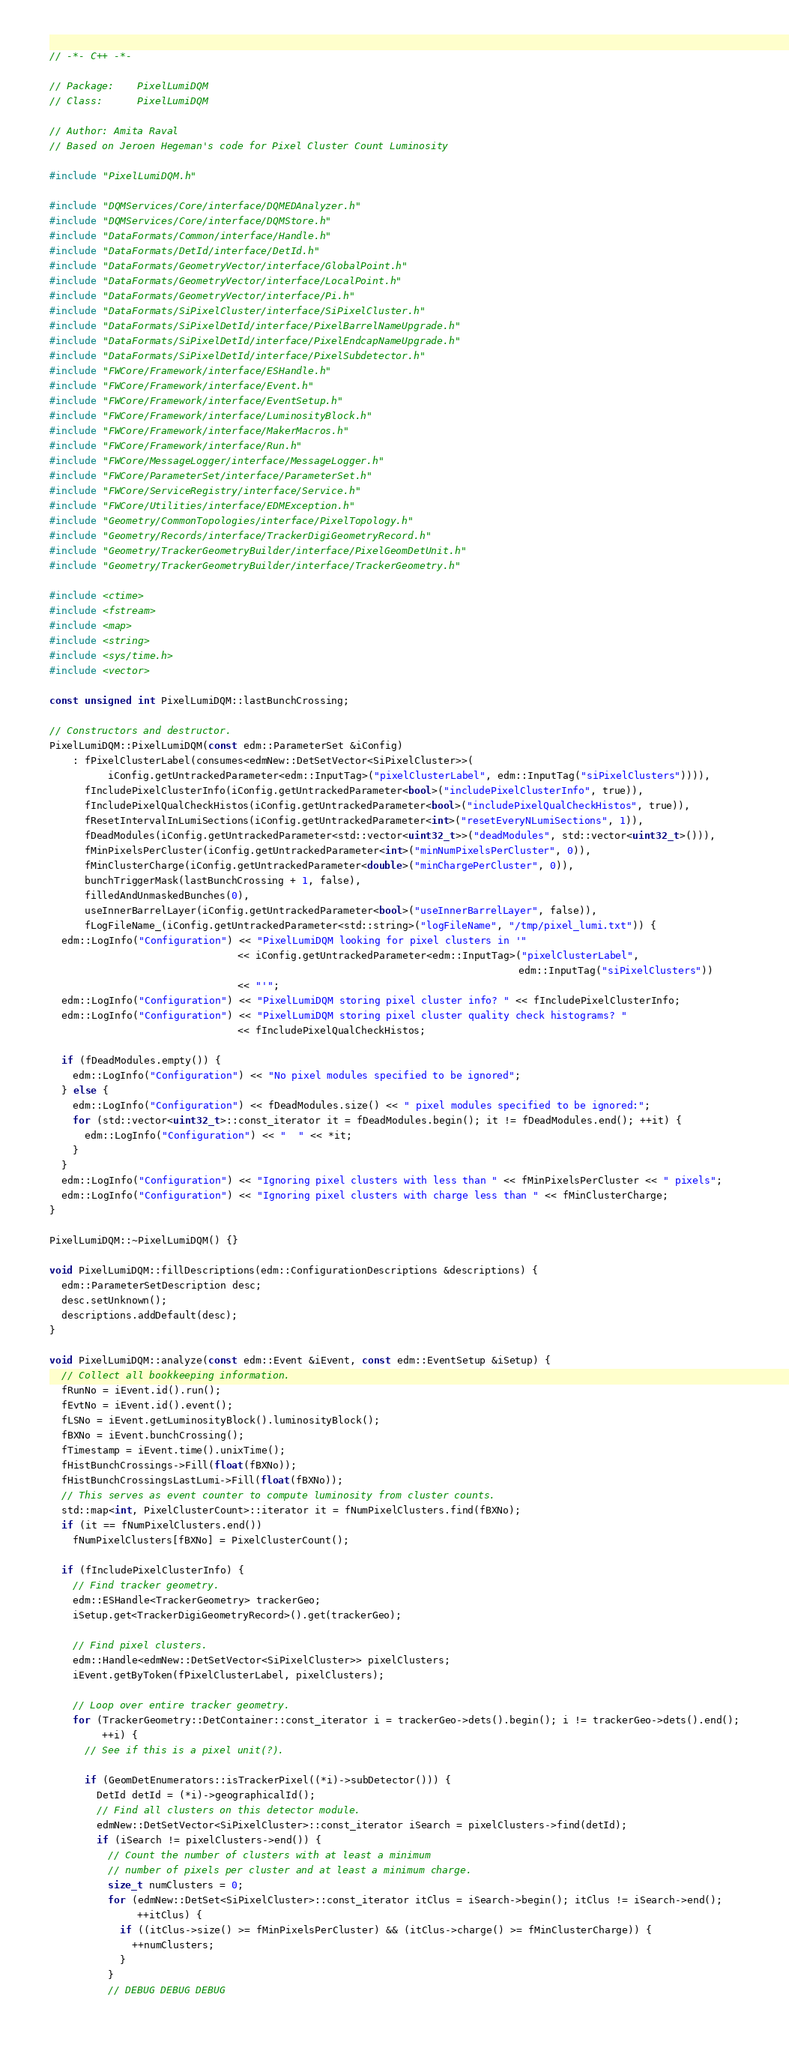Convert code to text. <code><loc_0><loc_0><loc_500><loc_500><_C++_>// -*- C++ -*-

// Package:    PixelLumiDQM
// Class:      PixelLumiDQM

// Author: Amita Raval
// Based on Jeroen Hegeman's code for Pixel Cluster Count Luminosity

#include "PixelLumiDQM.h"

#include "DQMServices/Core/interface/DQMEDAnalyzer.h"
#include "DQMServices/Core/interface/DQMStore.h"
#include "DataFormats/Common/interface/Handle.h"
#include "DataFormats/DetId/interface/DetId.h"
#include "DataFormats/GeometryVector/interface/GlobalPoint.h"
#include "DataFormats/GeometryVector/interface/LocalPoint.h"
#include "DataFormats/GeometryVector/interface/Pi.h"
#include "DataFormats/SiPixelCluster/interface/SiPixelCluster.h"
#include "DataFormats/SiPixelDetId/interface/PixelBarrelNameUpgrade.h"
#include "DataFormats/SiPixelDetId/interface/PixelEndcapNameUpgrade.h"
#include "DataFormats/SiPixelDetId/interface/PixelSubdetector.h"
#include "FWCore/Framework/interface/ESHandle.h"
#include "FWCore/Framework/interface/Event.h"
#include "FWCore/Framework/interface/EventSetup.h"
#include "FWCore/Framework/interface/LuminosityBlock.h"
#include "FWCore/Framework/interface/MakerMacros.h"
#include "FWCore/Framework/interface/Run.h"
#include "FWCore/MessageLogger/interface/MessageLogger.h"
#include "FWCore/ParameterSet/interface/ParameterSet.h"
#include "FWCore/ServiceRegistry/interface/Service.h"
#include "FWCore/Utilities/interface/EDMException.h"
#include "Geometry/CommonTopologies/interface/PixelTopology.h"
#include "Geometry/Records/interface/TrackerDigiGeometryRecord.h"
#include "Geometry/TrackerGeometryBuilder/interface/PixelGeomDetUnit.h"
#include "Geometry/TrackerGeometryBuilder/interface/TrackerGeometry.h"

#include <ctime>
#include <fstream>
#include <map>
#include <string>
#include <sys/time.h>
#include <vector>

const unsigned int PixelLumiDQM::lastBunchCrossing;

// Constructors and destructor.
PixelLumiDQM::PixelLumiDQM(const edm::ParameterSet &iConfig)
    : fPixelClusterLabel(consumes<edmNew::DetSetVector<SiPixelCluster>>(
          iConfig.getUntrackedParameter<edm::InputTag>("pixelClusterLabel", edm::InputTag("siPixelClusters")))),
      fIncludePixelClusterInfo(iConfig.getUntrackedParameter<bool>("includePixelClusterInfo", true)),
      fIncludePixelQualCheckHistos(iConfig.getUntrackedParameter<bool>("includePixelQualCheckHistos", true)),
      fResetIntervalInLumiSections(iConfig.getUntrackedParameter<int>("resetEveryNLumiSections", 1)),
      fDeadModules(iConfig.getUntrackedParameter<std::vector<uint32_t>>("deadModules", std::vector<uint32_t>())),
      fMinPixelsPerCluster(iConfig.getUntrackedParameter<int>("minNumPixelsPerCluster", 0)),
      fMinClusterCharge(iConfig.getUntrackedParameter<double>("minChargePerCluster", 0)),
      bunchTriggerMask(lastBunchCrossing + 1, false),
      filledAndUnmaskedBunches(0),
      useInnerBarrelLayer(iConfig.getUntrackedParameter<bool>("useInnerBarrelLayer", false)),
      fLogFileName_(iConfig.getUntrackedParameter<std::string>("logFileName", "/tmp/pixel_lumi.txt")) {
  edm::LogInfo("Configuration") << "PixelLumiDQM looking for pixel clusters in '"
                                << iConfig.getUntrackedParameter<edm::InputTag>("pixelClusterLabel",
                                                                                edm::InputTag("siPixelClusters"))
                                << "'";
  edm::LogInfo("Configuration") << "PixelLumiDQM storing pixel cluster info? " << fIncludePixelClusterInfo;
  edm::LogInfo("Configuration") << "PixelLumiDQM storing pixel cluster quality check histograms? "
                                << fIncludePixelQualCheckHistos;

  if (fDeadModules.empty()) {
    edm::LogInfo("Configuration") << "No pixel modules specified to be ignored";
  } else {
    edm::LogInfo("Configuration") << fDeadModules.size() << " pixel modules specified to be ignored:";
    for (std::vector<uint32_t>::const_iterator it = fDeadModules.begin(); it != fDeadModules.end(); ++it) {
      edm::LogInfo("Configuration") << "  " << *it;
    }
  }
  edm::LogInfo("Configuration") << "Ignoring pixel clusters with less than " << fMinPixelsPerCluster << " pixels";
  edm::LogInfo("Configuration") << "Ignoring pixel clusters with charge less than " << fMinClusterCharge;
}

PixelLumiDQM::~PixelLumiDQM() {}

void PixelLumiDQM::fillDescriptions(edm::ConfigurationDescriptions &descriptions) {
  edm::ParameterSetDescription desc;
  desc.setUnknown();
  descriptions.addDefault(desc);
}

void PixelLumiDQM::analyze(const edm::Event &iEvent, const edm::EventSetup &iSetup) {
  // Collect all bookkeeping information.
  fRunNo = iEvent.id().run();
  fEvtNo = iEvent.id().event();
  fLSNo = iEvent.getLuminosityBlock().luminosityBlock();
  fBXNo = iEvent.bunchCrossing();
  fTimestamp = iEvent.time().unixTime();
  fHistBunchCrossings->Fill(float(fBXNo));
  fHistBunchCrossingsLastLumi->Fill(float(fBXNo));
  // This serves as event counter to compute luminosity from cluster counts.
  std::map<int, PixelClusterCount>::iterator it = fNumPixelClusters.find(fBXNo);
  if (it == fNumPixelClusters.end())
    fNumPixelClusters[fBXNo] = PixelClusterCount();

  if (fIncludePixelClusterInfo) {
    // Find tracker geometry.
    edm::ESHandle<TrackerGeometry> trackerGeo;
    iSetup.get<TrackerDigiGeometryRecord>().get(trackerGeo);

    // Find pixel clusters.
    edm::Handle<edmNew::DetSetVector<SiPixelCluster>> pixelClusters;
    iEvent.getByToken(fPixelClusterLabel, pixelClusters);

    // Loop over entire tracker geometry.
    for (TrackerGeometry::DetContainer::const_iterator i = trackerGeo->dets().begin(); i != trackerGeo->dets().end();
         ++i) {
      // See if this is a pixel unit(?).

      if (GeomDetEnumerators::isTrackerPixel((*i)->subDetector())) {
        DetId detId = (*i)->geographicalId();
        // Find all clusters on this detector module.
        edmNew::DetSetVector<SiPixelCluster>::const_iterator iSearch = pixelClusters->find(detId);
        if (iSearch != pixelClusters->end()) {
          // Count the number of clusters with at least a minimum
          // number of pixels per cluster and at least a minimum charge.
          size_t numClusters = 0;
          for (edmNew::DetSet<SiPixelCluster>::const_iterator itClus = iSearch->begin(); itClus != iSearch->end();
               ++itClus) {
            if ((itClus->size() >= fMinPixelsPerCluster) && (itClus->charge() >= fMinClusterCharge)) {
              ++numClusters;
            }
          }
          // DEBUG DEBUG DEBUG</code> 